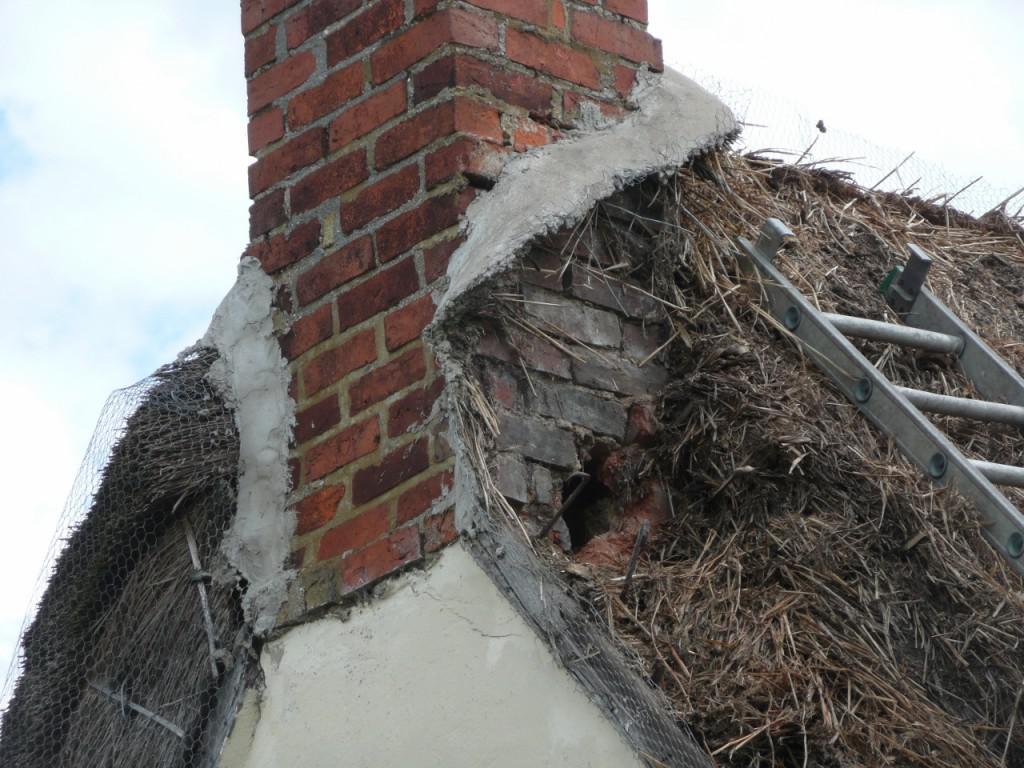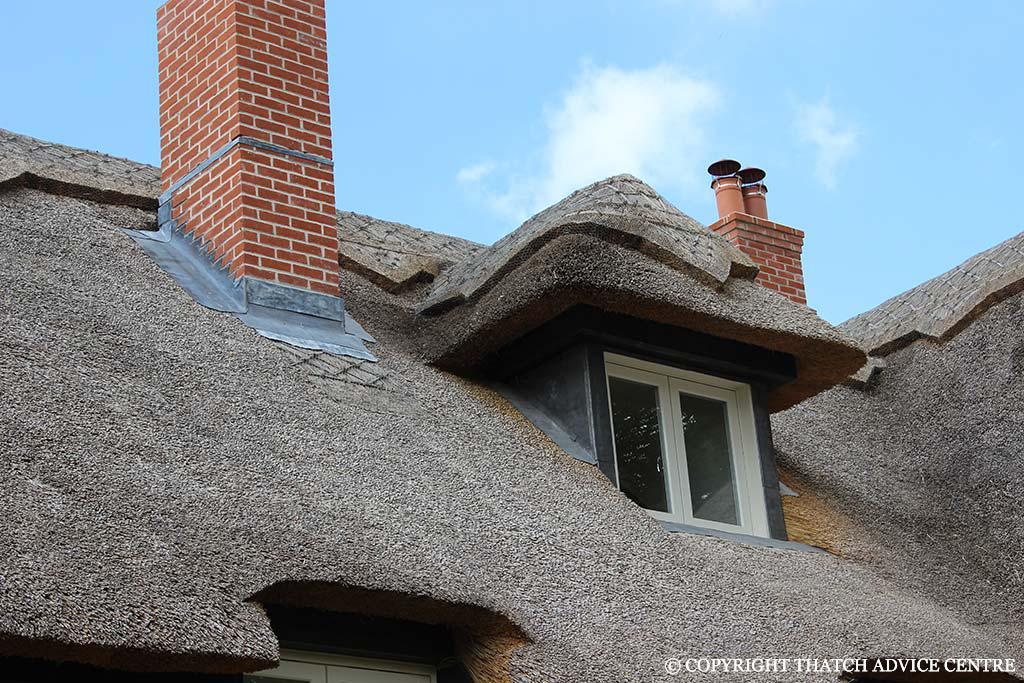The first image is the image on the left, the second image is the image on the right. Analyze the images presented: Is the assertion "In at least one image there is a silver ladder placed on the roof pointed toward the brick chimney." valid? Answer yes or no. Yes. The first image is the image on the left, the second image is the image on the right. Considering the images on both sides, is "The left image shows a ladder leaning against a thatched roof, with the top of the ladder near a red brick chimney." valid? Answer yes or no. Yes. 